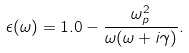<formula> <loc_0><loc_0><loc_500><loc_500>\epsilon ( \omega ) = 1 . 0 - \frac { \omega _ { p } ^ { 2 } } { \omega ( \omega + i \gamma ) } .</formula> 